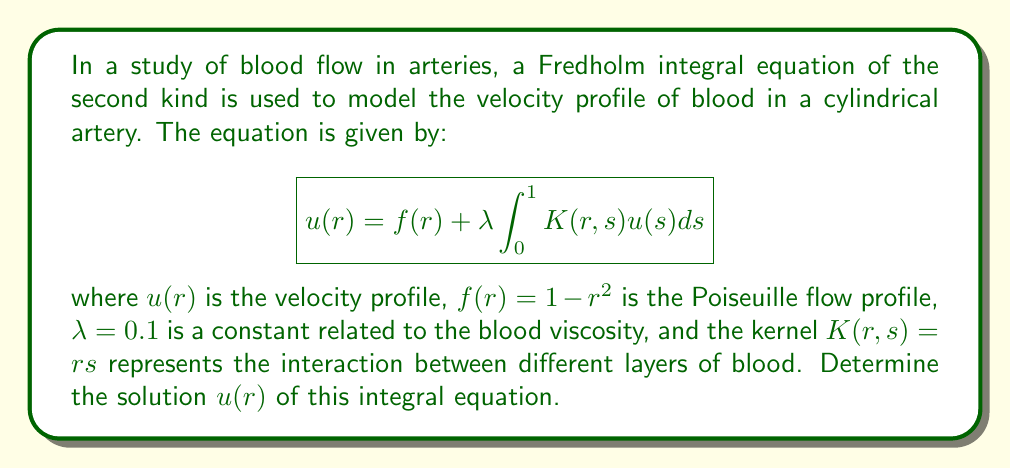Can you solve this math problem? To solve this Fredholm integral equation, we'll use the method of successive approximations:

1) Start with the initial approximation $u_0(r) = f(r) = 1 - r^2$.

2) Use the iterative formula:
   $$u_{n+1}(r) = f(r) + \lambda \int_0^1 K(r,s) u_n(s) ds$$

3) First iteration:
   $$\begin{align}
   u_1(r) &= (1-r^2) + 0.1 \int_0^1 rs(1-s^2) ds \\
   &= (1-r^2) + 0.1r \left[\frac{s^2}{2} - \frac{s^4}{4}\right]_0^1 \\
   &= (1-r^2) + 0.1r \left(\frac{1}{2} - \frac{1}{4}\right) \\
   &= 1 - r^2 + 0.025r
   \end{align}$$

4) Second iteration:
   $$\begin{align}
   u_2(r) &= (1-r^2) + 0.1 \int_0^1 rs(1-s^2+0.025s) ds \\
   &= (1-r^2) + 0.1r \left[\frac{s^2}{2} - \frac{s^4}{4} + \frac{0.025s^2}{2}\right]_0^1 \\
   &= (1-r^2) + 0.1r \left(\frac{1}{2} - \frac{1}{4} + \frac{0.025}{2}\right) \\
   &= 1 - r^2 + 0.02625r
   \end{align}$$

5) The solution converges quickly. We can see that the coefficient of $r$ is changing very little between iterations.

6) The exact solution can be found by assuming a form $u(r) = A + Br + Cr^2$ and solving for the coefficients:
   $$\begin{align}
   A + Br + Cr^2 &= (1-r^2) + 0.1 \int_0^1 rs(A + Bs + Cs^2) ds \\
   &= 1 - r^2 + 0.1r \left(A\frac{1}{2} + B\frac{1}{3} + C\frac{1}{4}\right)
   \end{align}$$

7) Equating coefficients:
   $$\begin{cases}
   A = 1 \\
   B = 0.1 \left(A\frac{1}{2} + B\frac{1}{3} + C\frac{1}{4}\right) \\
   C = -1
   \end{cases}$$

8) Solving this system of equations:
   $$A = 1, \quad B = \frac{1}{38}, \quad C = -1$$

Therefore, the exact solution is:
$$u(r) = 1 + \frac{1}{38}r - r^2$$
Answer: $u(r) = 1 + \frac{1}{38}r - r^2$ 